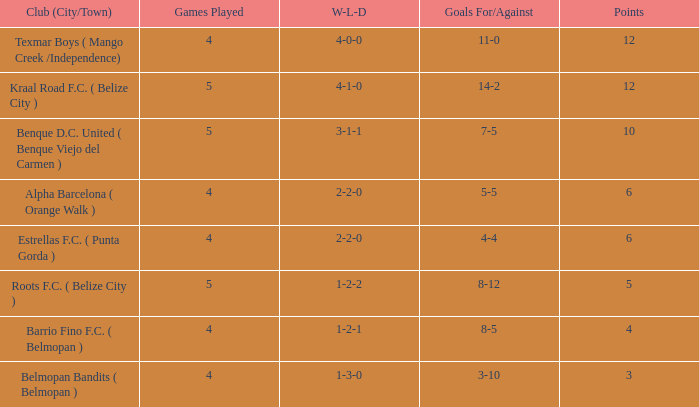What's the goals for/against with w-l-d being 3-1-1 7-5. 